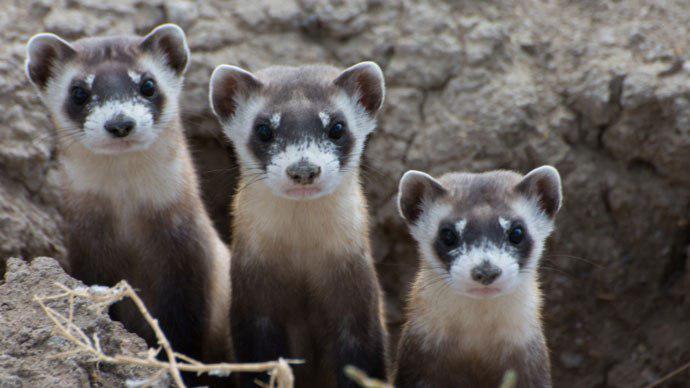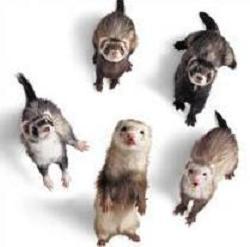The first image is the image on the left, the second image is the image on the right. Evaluate the accuracy of this statement regarding the images: "Three prairie dogs are poking their heads out of the ground in one of the images.". Is it true? Answer yes or no. Yes. 